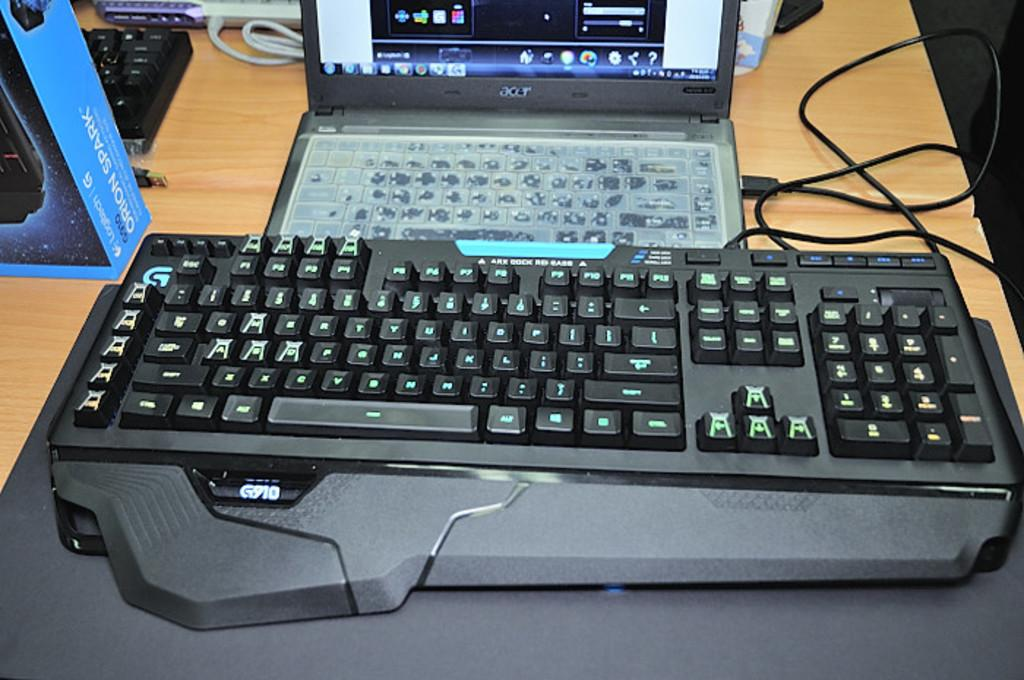What is the main piece of furniture in the image? There is a table in the image. What electronic devices are on the table? There are keyboards and laptops on the table. What else can be seen on the table besides the keyboards and laptops? There are wires visible on the table, a box, and some unspecified objects. Where is the meeting taking place in the image? There is no meeting taking place in the image; it only shows a table with various objects on it. 